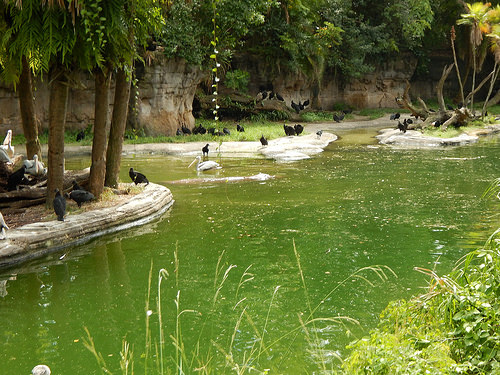<image>
Is there a tree to the left of the bird? Yes. From this viewpoint, the tree is positioned to the left side relative to the bird. Where is the duck in relation to the water? Is it in the water? No. The duck is not contained within the water. These objects have a different spatial relationship. 